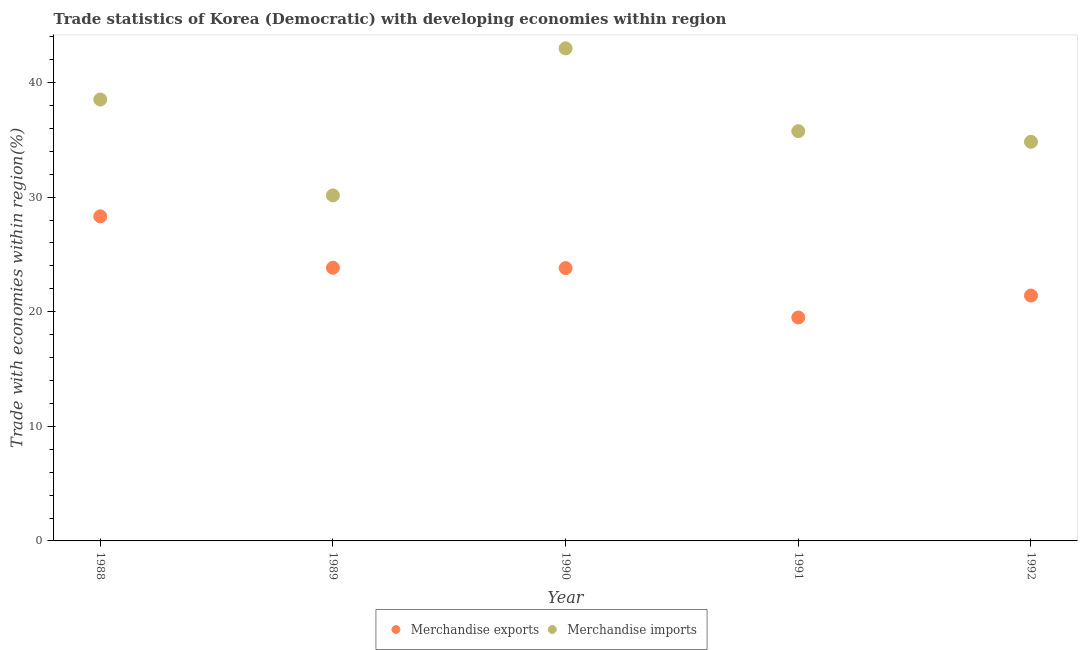How many different coloured dotlines are there?
Offer a terse response. 2. Is the number of dotlines equal to the number of legend labels?
Ensure brevity in your answer.  Yes. What is the merchandise imports in 1989?
Keep it short and to the point. 30.15. Across all years, what is the maximum merchandise imports?
Provide a short and direct response. 42.98. Across all years, what is the minimum merchandise exports?
Your answer should be compact. 19.5. In which year was the merchandise exports maximum?
Make the answer very short. 1988. In which year was the merchandise exports minimum?
Offer a terse response. 1991. What is the total merchandise imports in the graph?
Ensure brevity in your answer.  182.23. What is the difference between the merchandise exports in 1989 and that in 1991?
Make the answer very short. 4.34. What is the difference between the merchandise imports in 1990 and the merchandise exports in 1992?
Keep it short and to the point. 21.57. What is the average merchandise imports per year?
Give a very brief answer. 36.45. In the year 1992, what is the difference between the merchandise imports and merchandise exports?
Your answer should be very brief. 13.42. In how many years, is the merchandise exports greater than 10 %?
Ensure brevity in your answer.  5. What is the ratio of the merchandise exports in 1989 to that in 1992?
Keep it short and to the point. 1.11. Is the merchandise imports in 1988 less than that in 1989?
Provide a succinct answer. No. What is the difference between the highest and the second highest merchandise imports?
Your answer should be compact. 4.47. What is the difference between the highest and the lowest merchandise imports?
Keep it short and to the point. 12.83. How many dotlines are there?
Your answer should be very brief. 2. How many years are there in the graph?
Provide a short and direct response. 5. How many legend labels are there?
Your response must be concise. 2. What is the title of the graph?
Provide a succinct answer. Trade statistics of Korea (Democratic) with developing economies within region. Does "Adolescent fertility rate" appear as one of the legend labels in the graph?
Ensure brevity in your answer.  No. What is the label or title of the X-axis?
Ensure brevity in your answer.  Year. What is the label or title of the Y-axis?
Keep it short and to the point. Trade with economies within region(%). What is the Trade with economies within region(%) of Merchandise exports in 1988?
Ensure brevity in your answer.  28.32. What is the Trade with economies within region(%) in Merchandise imports in 1988?
Your answer should be compact. 38.52. What is the Trade with economies within region(%) in Merchandise exports in 1989?
Offer a very short reply. 23.83. What is the Trade with economies within region(%) in Merchandise imports in 1989?
Your answer should be very brief. 30.15. What is the Trade with economies within region(%) of Merchandise exports in 1990?
Offer a terse response. 23.81. What is the Trade with economies within region(%) in Merchandise imports in 1990?
Provide a short and direct response. 42.98. What is the Trade with economies within region(%) in Merchandise exports in 1991?
Your answer should be very brief. 19.5. What is the Trade with economies within region(%) of Merchandise imports in 1991?
Give a very brief answer. 35.75. What is the Trade with economies within region(%) of Merchandise exports in 1992?
Keep it short and to the point. 21.41. What is the Trade with economies within region(%) in Merchandise imports in 1992?
Your response must be concise. 34.83. Across all years, what is the maximum Trade with economies within region(%) of Merchandise exports?
Offer a terse response. 28.32. Across all years, what is the maximum Trade with economies within region(%) in Merchandise imports?
Provide a succinct answer. 42.98. Across all years, what is the minimum Trade with economies within region(%) in Merchandise exports?
Your answer should be compact. 19.5. Across all years, what is the minimum Trade with economies within region(%) in Merchandise imports?
Provide a short and direct response. 30.15. What is the total Trade with economies within region(%) in Merchandise exports in the graph?
Provide a succinct answer. 116.87. What is the total Trade with economies within region(%) of Merchandise imports in the graph?
Offer a terse response. 182.23. What is the difference between the Trade with economies within region(%) in Merchandise exports in 1988 and that in 1989?
Provide a succinct answer. 4.49. What is the difference between the Trade with economies within region(%) in Merchandise imports in 1988 and that in 1989?
Provide a succinct answer. 8.37. What is the difference between the Trade with economies within region(%) of Merchandise exports in 1988 and that in 1990?
Your answer should be compact. 4.52. What is the difference between the Trade with economies within region(%) in Merchandise imports in 1988 and that in 1990?
Give a very brief answer. -4.47. What is the difference between the Trade with economies within region(%) in Merchandise exports in 1988 and that in 1991?
Give a very brief answer. 8.83. What is the difference between the Trade with economies within region(%) in Merchandise imports in 1988 and that in 1991?
Ensure brevity in your answer.  2.76. What is the difference between the Trade with economies within region(%) of Merchandise exports in 1988 and that in 1992?
Make the answer very short. 6.91. What is the difference between the Trade with economies within region(%) of Merchandise imports in 1988 and that in 1992?
Your response must be concise. 3.69. What is the difference between the Trade with economies within region(%) in Merchandise exports in 1989 and that in 1990?
Provide a succinct answer. 0.03. What is the difference between the Trade with economies within region(%) in Merchandise imports in 1989 and that in 1990?
Make the answer very short. -12.83. What is the difference between the Trade with economies within region(%) of Merchandise exports in 1989 and that in 1991?
Provide a short and direct response. 4.34. What is the difference between the Trade with economies within region(%) in Merchandise imports in 1989 and that in 1991?
Offer a very short reply. -5.6. What is the difference between the Trade with economies within region(%) in Merchandise exports in 1989 and that in 1992?
Offer a terse response. 2.42. What is the difference between the Trade with economies within region(%) in Merchandise imports in 1989 and that in 1992?
Provide a succinct answer. -4.68. What is the difference between the Trade with economies within region(%) of Merchandise exports in 1990 and that in 1991?
Your answer should be compact. 4.31. What is the difference between the Trade with economies within region(%) in Merchandise imports in 1990 and that in 1991?
Make the answer very short. 7.23. What is the difference between the Trade with economies within region(%) in Merchandise exports in 1990 and that in 1992?
Your response must be concise. 2.4. What is the difference between the Trade with economies within region(%) of Merchandise imports in 1990 and that in 1992?
Provide a short and direct response. 8.16. What is the difference between the Trade with economies within region(%) of Merchandise exports in 1991 and that in 1992?
Your response must be concise. -1.92. What is the difference between the Trade with economies within region(%) of Merchandise imports in 1991 and that in 1992?
Offer a very short reply. 0.93. What is the difference between the Trade with economies within region(%) of Merchandise exports in 1988 and the Trade with economies within region(%) of Merchandise imports in 1989?
Keep it short and to the point. -1.83. What is the difference between the Trade with economies within region(%) of Merchandise exports in 1988 and the Trade with economies within region(%) of Merchandise imports in 1990?
Keep it short and to the point. -14.66. What is the difference between the Trade with economies within region(%) of Merchandise exports in 1988 and the Trade with economies within region(%) of Merchandise imports in 1991?
Offer a very short reply. -7.43. What is the difference between the Trade with economies within region(%) in Merchandise exports in 1988 and the Trade with economies within region(%) in Merchandise imports in 1992?
Provide a succinct answer. -6.5. What is the difference between the Trade with economies within region(%) in Merchandise exports in 1989 and the Trade with economies within region(%) in Merchandise imports in 1990?
Offer a terse response. -19.15. What is the difference between the Trade with economies within region(%) in Merchandise exports in 1989 and the Trade with economies within region(%) in Merchandise imports in 1991?
Offer a very short reply. -11.92. What is the difference between the Trade with economies within region(%) of Merchandise exports in 1989 and the Trade with economies within region(%) of Merchandise imports in 1992?
Provide a succinct answer. -10.99. What is the difference between the Trade with economies within region(%) of Merchandise exports in 1990 and the Trade with economies within region(%) of Merchandise imports in 1991?
Ensure brevity in your answer.  -11.95. What is the difference between the Trade with economies within region(%) in Merchandise exports in 1990 and the Trade with economies within region(%) in Merchandise imports in 1992?
Your answer should be compact. -11.02. What is the difference between the Trade with economies within region(%) in Merchandise exports in 1991 and the Trade with economies within region(%) in Merchandise imports in 1992?
Keep it short and to the point. -15.33. What is the average Trade with economies within region(%) in Merchandise exports per year?
Your response must be concise. 23.37. What is the average Trade with economies within region(%) of Merchandise imports per year?
Your response must be concise. 36.45. In the year 1988, what is the difference between the Trade with economies within region(%) in Merchandise exports and Trade with economies within region(%) in Merchandise imports?
Ensure brevity in your answer.  -10.19. In the year 1989, what is the difference between the Trade with economies within region(%) of Merchandise exports and Trade with economies within region(%) of Merchandise imports?
Make the answer very short. -6.31. In the year 1990, what is the difference between the Trade with economies within region(%) in Merchandise exports and Trade with economies within region(%) in Merchandise imports?
Offer a terse response. -19.18. In the year 1991, what is the difference between the Trade with economies within region(%) in Merchandise exports and Trade with economies within region(%) in Merchandise imports?
Your answer should be compact. -16.26. In the year 1992, what is the difference between the Trade with economies within region(%) of Merchandise exports and Trade with economies within region(%) of Merchandise imports?
Provide a short and direct response. -13.42. What is the ratio of the Trade with economies within region(%) of Merchandise exports in 1988 to that in 1989?
Ensure brevity in your answer.  1.19. What is the ratio of the Trade with economies within region(%) in Merchandise imports in 1988 to that in 1989?
Your answer should be compact. 1.28. What is the ratio of the Trade with economies within region(%) in Merchandise exports in 1988 to that in 1990?
Provide a short and direct response. 1.19. What is the ratio of the Trade with economies within region(%) of Merchandise imports in 1988 to that in 1990?
Give a very brief answer. 0.9. What is the ratio of the Trade with economies within region(%) of Merchandise exports in 1988 to that in 1991?
Your answer should be very brief. 1.45. What is the ratio of the Trade with economies within region(%) in Merchandise imports in 1988 to that in 1991?
Provide a succinct answer. 1.08. What is the ratio of the Trade with economies within region(%) in Merchandise exports in 1988 to that in 1992?
Make the answer very short. 1.32. What is the ratio of the Trade with economies within region(%) of Merchandise imports in 1988 to that in 1992?
Your answer should be very brief. 1.11. What is the ratio of the Trade with economies within region(%) in Merchandise exports in 1989 to that in 1990?
Provide a succinct answer. 1. What is the ratio of the Trade with economies within region(%) in Merchandise imports in 1989 to that in 1990?
Give a very brief answer. 0.7. What is the ratio of the Trade with economies within region(%) of Merchandise exports in 1989 to that in 1991?
Ensure brevity in your answer.  1.22. What is the ratio of the Trade with economies within region(%) in Merchandise imports in 1989 to that in 1991?
Make the answer very short. 0.84. What is the ratio of the Trade with economies within region(%) in Merchandise exports in 1989 to that in 1992?
Provide a succinct answer. 1.11. What is the ratio of the Trade with economies within region(%) in Merchandise imports in 1989 to that in 1992?
Offer a very short reply. 0.87. What is the ratio of the Trade with economies within region(%) in Merchandise exports in 1990 to that in 1991?
Keep it short and to the point. 1.22. What is the ratio of the Trade with economies within region(%) of Merchandise imports in 1990 to that in 1991?
Your response must be concise. 1.2. What is the ratio of the Trade with economies within region(%) in Merchandise exports in 1990 to that in 1992?
Your response must be concise. 1.11. What is the ratio of the Trade with economies within region(%) in Merchandise imports in 1990 to that in 1992?
Give a very brief answer. 1.23. What is the ratio of the Trade with economies within region(%) in Merchandise exports in 1991 to that in 1992?
Keep it short and to the point. 0.91. What is the ratio of the Trade with economies within region(%) of Merchandise imports in 1991 to that in 1992?
Ensure brevity in your answer.  1.03. What is the difference between the highest and the second highest Trade with economies within region(%) in Merchandise exports?
Ensure brevity in your answer.  4.49. What is the difference between the highest and the second highest Trade with economies within region(%) of Merchandise imports?
Your answer should be compact. 4.47. What is the difference between the highest and the lowest Trade with economies within region(%) in Merchandise exports?
Give a very brief answer. 8.83. What is the difference between the highest and the lowest Trade with economies within region(%) of Merchandise imports?
Provide a short and direct response. 12.83. 